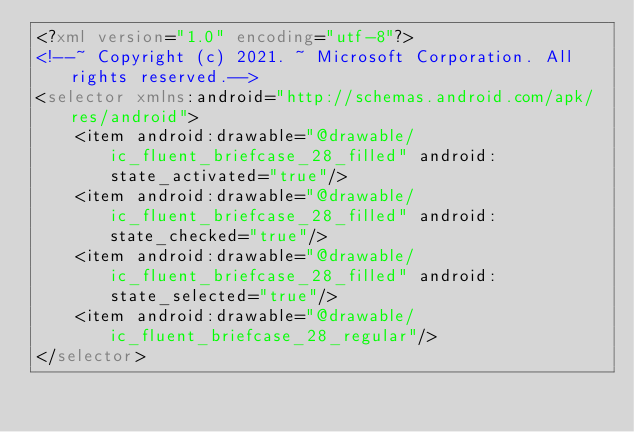<code> <loc_0><loc_0><loc_500><loc_500><_XML_><?xml version="1.0" encoding="utf-8"?>
<!--~ Copyright (c) 2021. ~ Microsoft Corporation. All rights reserved.-->
<selector xmlns:android="http://schemas.android.com/apk/res/android">
    <item android:drawable="@drawable/ic_fluent_briefcase_28_filled" android:state_activated="true"/>
    <item android:drawable="@drawable/ic_fluent_briefcase_28_filled" android:state_checked="true"/>
    <item android:drawable="@drawable/ic_fluent_briefcase_28_filled" android:state_selected="true"/>
    <item android:drawable="@drawable/ic_fluent_briefcase_28_regular"/>
</selector>
</code> 